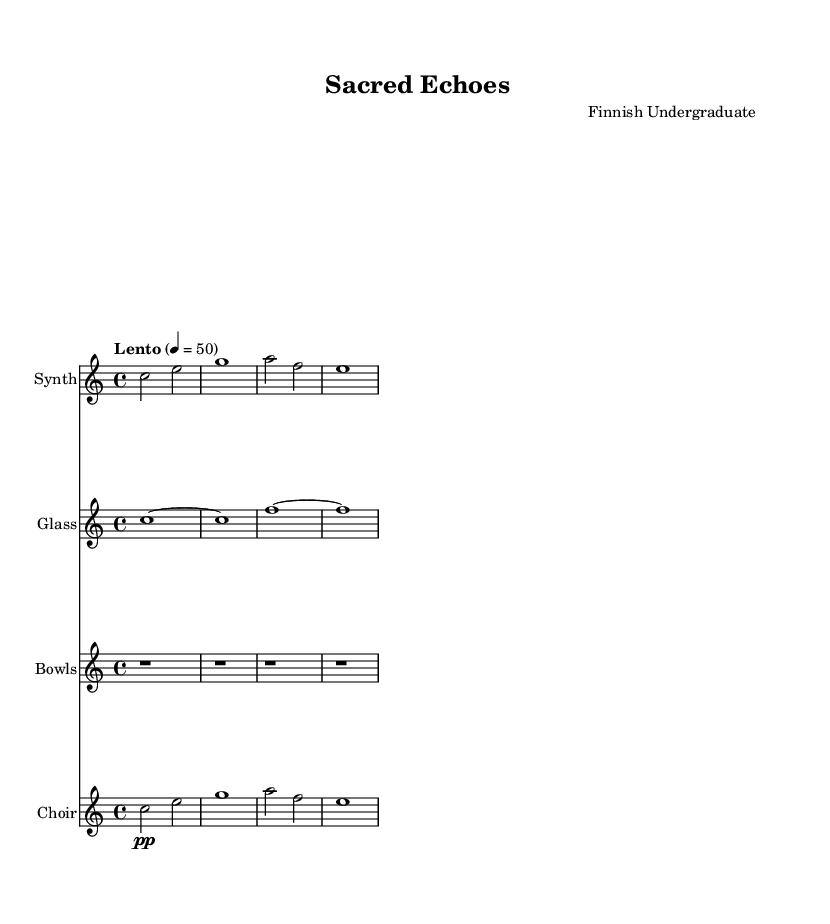What is the key signature of this music? The key signature is C major, which has no sharps or flats indicated by the absence of any sharp or flat symbols at the beginning of the staff.
Answer: C major What is the time signature of this music? The time signature is 4/4. This is shown at the beginning of the piece, indicating four beats per measure.
Answer: 4/4 What is the tempo marking for this piece? The tempo marking indicates "Lento," suggesting a slow pace. This is specified above the staff, giving a clear instruction on the speed of the performance.
Answer: Lento How many measures are present in the synthesizer part? The synthesizer part contains four measures, as counted from the beginning to the end of the notated section.
Answer: 4 Which instrument is playing the sustained rest throughout the piece? The Tibetan bowls are indicated to play rests for the entire duration, as shown by the repeated rests in the staff dedicated to this instrument.
Answer: Bowls What dynamic marking is indicated for the choir part? The choir part is marked "pp," which stands for "pianissimo," indicating that this section should be performed very softly. This is placed before the notes in the choir staff.
Answer: pp What type of texture is primarily present in this composition? The texture of the composition is primarily homophonic, as demonstrated by the melody lines supported by harmonic elements in the accompanying parts. This can be deduced by analyzing the simultaneous sounding of the synthesizer and choir parts.
Answer: Homophonic 